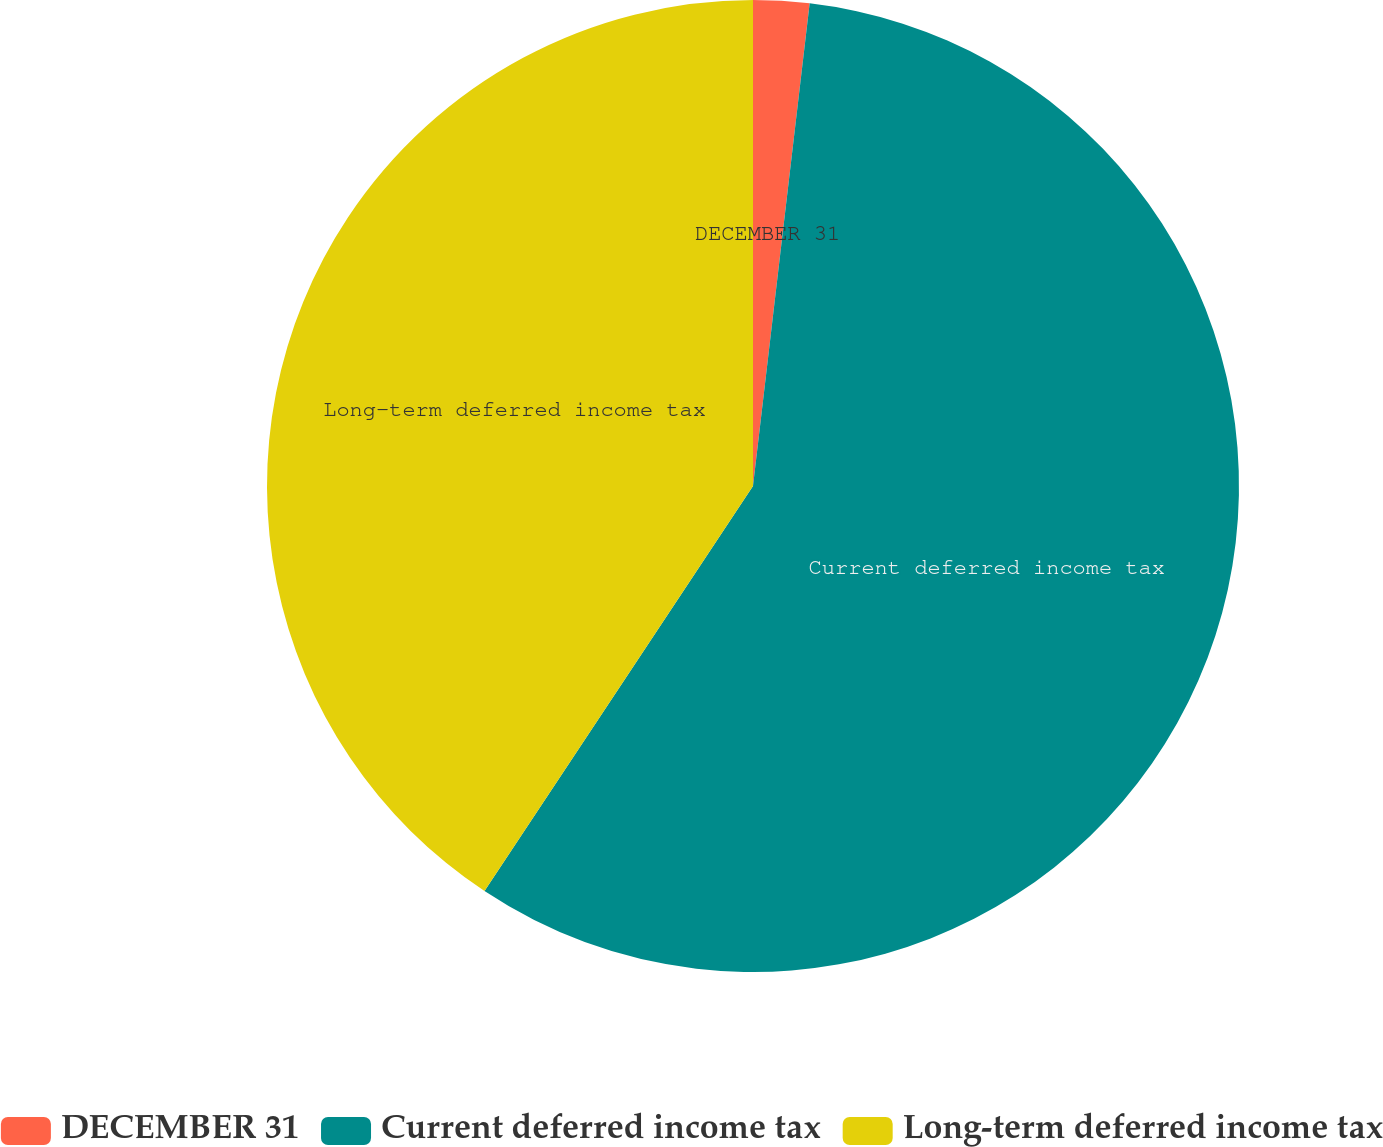Convert chart. <chart><loc_0><loc_0><loc_500><loc_500><pie_chart><fcel>DECEMBER 31<fcel>Current deferred income tax<fcel>Long-term deferred income tax<nl><fcel>1.86%<fcel>57.45%<fcel>40.68%<nl></chart> 